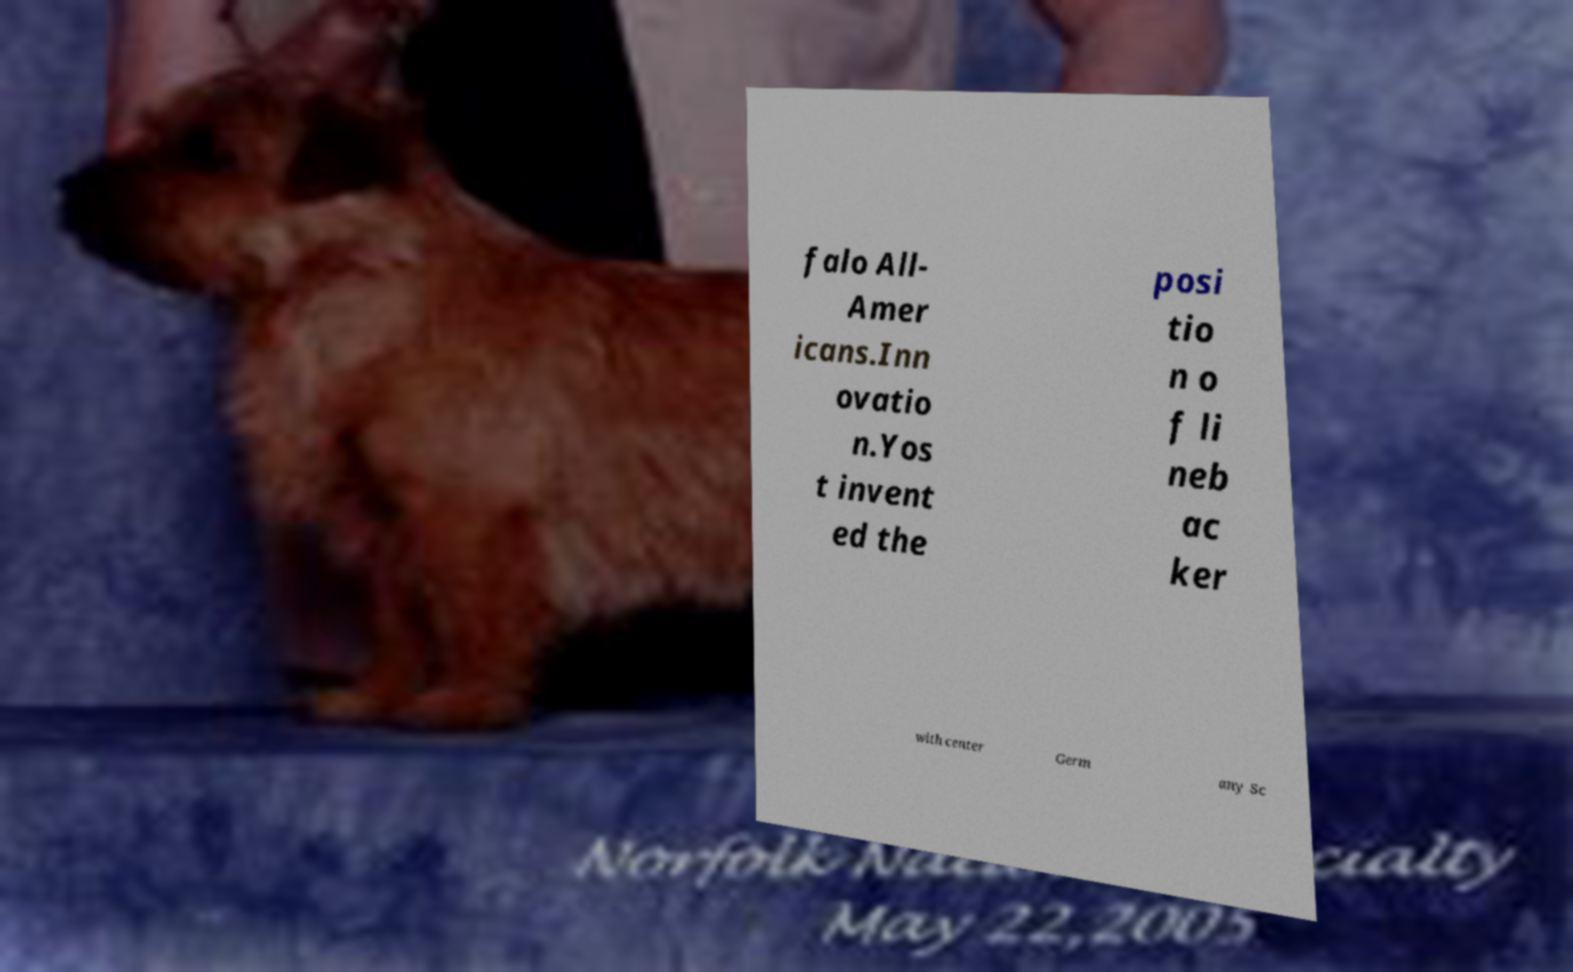Could you assist in decoding the text presented in this image and type it out clearly? falo All- Amer icans.Inn ovatio n.Yos t invent ed the posi tio n o f li neb ac ker with center Germ any Sc 